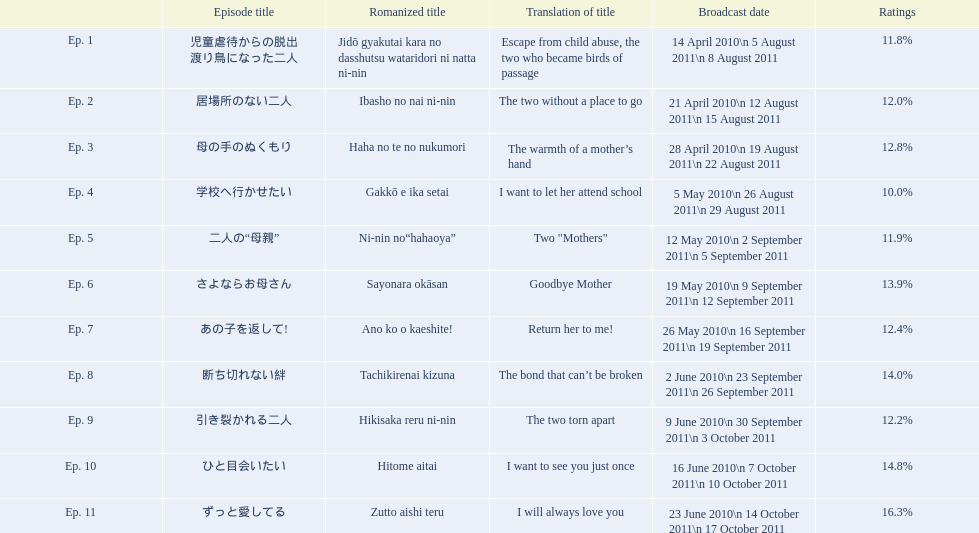What are the numbers of the episodes? Ep. 1, Ep. 2, Ep. 3, Ep. 4, Ep. 5, Ep. 6, Ep. 7, Ep. 8, Ep. 9, Ep. 10, Ep. 11. What percentage of total ratings did episode 8 receive? 14.0%. 